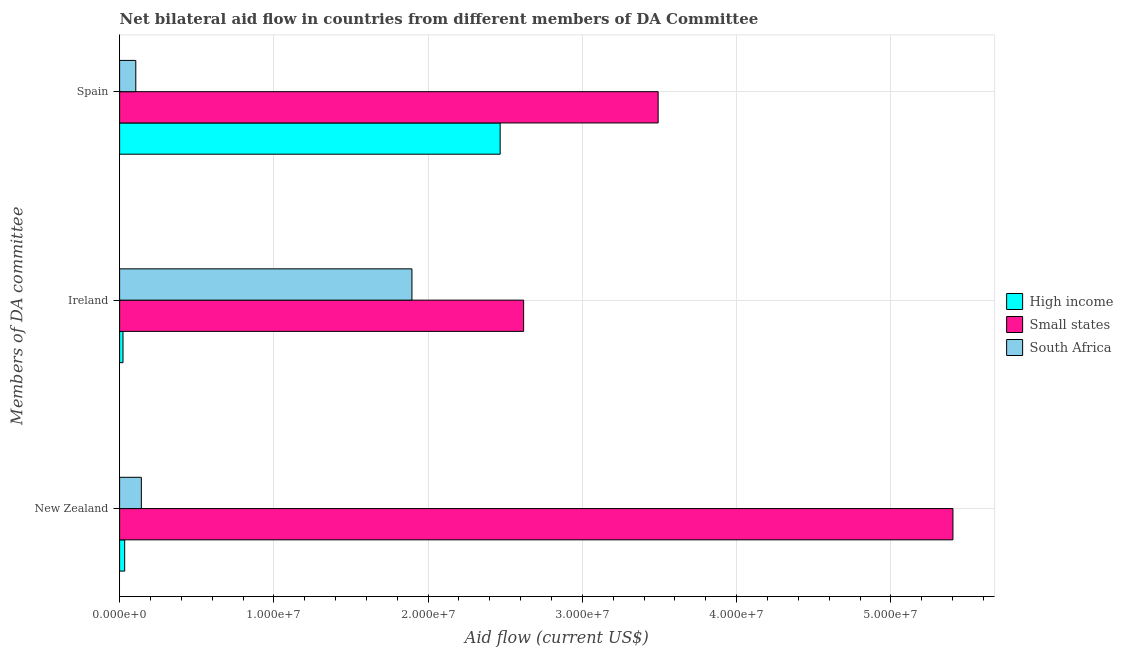How many different coloured bars are there?
Offer a terse response. 3. Are the number of bars on each tick of the Y-axis equal?
Offer a terse response. Yes. How many bars are there on the 3rd tick from the top?
Provide a short and direct response. 3. How many bars are there on the 2nd tick from the bottom?
Provide a short and direct response. 3. What is the label of the 2nd group of bars from the top?
Your answer should be compact. Ireland. What is the amount of aid provided by ireland in Small states?
Your answer should be compact. 2.62e+07. Across all countries, what is the maximum amount of aid provided by new zealand?
Your answer should be compact. 5.40e+07. Across all countries, what is the minimum amount of aid provided by new zealand?
Keep it short and to the point. 3.30e+05. In which country was the amount of aid provided by new zealand maximum?
Give a very brief answer. Small states. In which country was the amount of aid provided by spain minimum?
Provide a short and direct response. South Africa. What is the total amount of aid provided by spain in the graph?
Provide a short and direct response. 6.06e+07. What is the difference between the amount of aid provided by ireland in South Africa and that in High income?
Give a very brief answer. 1.87e+07. What is the difference between the amount of aid provided by spain in Small states and the amount of aid provided by new zealand in High income?
Give a very brief answer. 3.46e+07. What is the average amount of aid provided by spain per country?
Provide a short and direct response. 2.02e+07. What is the difference between the amount of aid provided by spain and amount of aid provided by new zealand in High income?
Offer a terse response. 2.43e+07. What is the ratio of the amount of aid provided by ireland in South Africa to that in High income?
Your answer should be very brief. 86.14. What is the difference between the highest and the second highest amount of aid provided by spain?
Give a very brief answer. 1.02e+07. What is the difference between the highest and the lowest amount of aid provided by new zealand?
Offer a terse response. 5.37e+07. In how many countries, is the amount of aid provided by spain greater than the average amount of aid provided by spain taken over all countries?
Provide a succinct answer. 2. Is the sum of the amount of aid provided by spain in Small states and South Africa greater than the maximum amount of aid provided by ireland across all countries?
Your answer should be compact. Yes. What does the 1st bar from the top in Spain represents?
Offer a very short reply. South Africa. What does the 3rd bar from the bottom in Spain represents?
Keep it short and to the point. South Africa. Is it the case that in every country, the sum of the amount of aid provided by new zealand and amount of aid provided by ireland is greater than the amount of aid provided by spain?
Your response must be concise. No. How many bars are there?
Provide a succinct answer. 9. Are all the bars in the graph horizontal?
Provide a short and direct response. Yes. Does the graph contain any zero values?
Your answer should be very brief. No. How many legend labels are there?
Keep it short and to the point. 3. How are the legend labels stacked?
Your response must be concise. Vertical. What is the title of the graph?
Offer a terse response. Net bilateral aid flow in countries from different members of DA Committee. Does "Cameroon" appear as one of the legend labels in the graph?
Your response must be concise. No. What is the label or title of the Y-axis?
Provide a succinct answer. Members of DA committee. What is the Aid flow (current US$) of Small states in New Zealand?
Your response must be concise. 5.40e+07. What is the Aid flow (current US$) of South Africa in New Zealand?
Provide a succinct answer. 1.41e+06. What is the Aid flow (current US$) of Small states in Ireland?
Ensure brevity in your answer.  2.62e+07. What is the Aid flow (current US$) of South Africa in Ireland?
Your response must be concise. 1.90e+07. What is the Aid flow (current US$) in High income in Spain?
Your answer should be very brief. 2.47e+07. What is the Aid flow (current US$) in Small states in Spain?
Give a very brief answer. 3.49e+07. What is the Aid flow (current US$) in South Africa in Spain?
Your answer should be very brief. 1.05e+06. Across all Members of DA committee, what is the maximum Aid flow (current US$) of High income?
Make the answer very short. 2.47e+07. Across all Members of DA committee, what is the maximum Aid flow (current US$) of Small states?
Your response must be concise. 5.40e+07. Across all Members of DA committee, what is the maximum Aid flow (current US$) in South Africa?
Ensure brevity in your answer.  1.90e+07. Across all Members of DA committee, what is the minimum Aid flow (current US$) in High income?
Provide a succinct answer. 2.20e+05. Across all Members of DA committee, what is the minimum Aid flow (current US$) of Small states?
Offer a terse response. 2.62e+07. Across all Members of DA committee, what is the minimum Aid flow (current US$) of South Africa?
Provide a succinct answer. 1.05e+06. What is the total Aid flow (current US$) of High income in the graph?
Your answer should be compact. 2.52e+07. What is the total Aid flow (current US$) in Small states in the graph?
Ensure brevity in your answer.  1.15e+08. What is the total Aid flow (current US$) of South Africa in the graph?
Give a very brief answer. 2.14e+07. What is the difference between the Aid flow (current US$) of High income in New Zealand and that in Ireland?
Your answer should be compact. 1.10e+05. What is the difference between the Aid flow (current US$) of Small states in New Zealand and that in Ireland?
Make the answer very short. 2.78e+07. What is the difference between the Aid flow (current US$) of South Africa in New Zealand and that in Ireland?
Offer a very short reply. -1.75e+07. What is the difference between the Aid flow (current US$) of High income in New Zealand and that in Spain?
Your answer should be very brief. -2.43e+07. What is the difference between the Aid flow (current US$) in Small states in New Zealand and that in Spain?
Your response must be concise. 1.91e+07. What is the difference between the Aid flow (current US$) of High income in Ireland and that in Spain?
Offer a terse response. -2.44e+07. What is the difference between the Aid flow (current US$) in Small states in Ireland and that in Spain?
Keep it short and to the point. -8.72e+06. What is the difference between the Aid flow (current US$) of South Africa in Ireland and that in Spain?
Your answer should be very brief. 1.79e+07. What is the difference between the Aid flow (current US$) of High income in New Zealand and the Aid flow (current US$) of Small states in Ireland?
Provide a short and direct response. -2.59e+07. What is the difference between the Aid flow (current US$) of High income in New Zealand and the Aid flow (current US$) of South Africa in Ireland?
Your response must be concise. -1.86e+07. What is the difference between the Aid flow (current US$) in Small states in New Zealand and the Aid flow (current US$) in South Africa in Ireland?
Make the answer very short. 3.51e+07. What is the difference between the Aid flow (current US$) in High income in New Zealand and the Aid flow (current US$) in Small states in Spain?
Provide a succinct answer. -3.46e+07. What is the difference between the Aid flow (current US$) of High income in New Zealand and the Aid flow (current US$) of South Africa in Spain?
Provide a short and direct response. -7.20e+05. What is the difference between the Aid flow (current US$) of Small states in New Zealand and the Aid flow (current US$) of South Africa in Spain?
Your answer should be compact. 5.30e+07. What is the difference between the Aid flow (current US$) in High income in Ireland and the Aid flow (current US$) in Small states in Spain?
Your answer should be very brief. -3.47e+07. What is the difference between the Aid flow (current US$) of High income in Ireland and the Aid flow (current US$) of South Africa in Spain?
Give a very brief answer. -8.30e+05. What is the difference between the Aid flow (current US$) in Small states in Ireland and the Aid flow (current US$) in South Africa in Spain?
Give a very brief answer. 2.51e+07. What is the average Aid flow (current US$) in High income per Members of DA committee?
Your answer should be compact. 8.41e+06. What is the average Aid flow (current US$) of Small states per Members of DA committee?
Your answer should be compact. 3.84e+07. What is the average Aid flow (current US$) in South Africa per Members of DA committee?
Ensure brevity in your answer.  7.14e+06. What is the difference between the Aid flow (current US$) in High income and Aid flow (current US$) in Small states in New Zealand?
Offer a very short reply. -5.37e+07. What is the difference between the Aid flow (current US$) in High income and Aid flow (current US$) in South Africa in New Zealand?
Make the answer very short. -1.08e+06. What is the difference between the Aid flow (current US$) in Small states and Aid flow (current US$) in South Africa in New Zealand?
Your response must be concise. 5.26e+07. What is the difference between the Aid flow (current US$) of High income and Aid flow (current US$) of Small states in Ireland?
Make the answer very short. -2.60e+07. What is the difference between the Aid flow (current US$) in High income and Aid flow (current US$) in South Africa in Ireland?
Make the answer very short. -1.87e+07. What is the difference between the Aid flow (current US$) of Small states and Aid flow (current US$) of South Africa in Ireland?
Keep it short and to the point. 7.24e+06. What is the difference between the Aid flow (current US$) of High income and Aid flow (current US$) of Small states in Spain?
Offer a very short reply. -1.02e+07. What is the difference between the Aid flow (current US$) in High income and Aid flow (current US$) in South Africa in Spain?
Make the answer very short. 2.36e+07. What is the difference between the Aid flow (current US$) of Small states and Aid flow (current US$) of South Africa in Spain?
Offer a very short reply. 3.39e+07. What is the ratio of the Aid flow (current US$) of Small states in New Zealand to that in Ireland?
Offer a very short reply. 2.06. What is the ratio of the Aid flow (current US$) of South Africa in New Zealand to that in Ireland?
Offer a very short reply. 0.07. What is the ratio of the Aid flow (current US$) of High income in New Zealand to that in Spain?
Provide a succinct answer. 0.01. What is the ratio of the Aid flow (current US$) in Small states in New Zealand to that in Spain?
Ensure brevity in your answer.  1.55. What is the ratio of the Aid flow (current US$) in South Africa in New Zealand to that in Spain?
Give a very brief answer. 1.34. What is the ratio of the Aid flow (current US$) in High income in Ireland to that in Spain?
Your response must be concise. 0.01. What is the ratio of the Aid flow (current US$) of Small states in Ireland to that in Spain?
Ensure brevity in your answer.  0.75. What is the ratio of the Aid flow (current US$) of South Africa in Ireland to that in Spain?
Make the answer very short. 18.05. What is the difference between the highest and the second highest Aid flow (current US$) of High income?
Provide a short and direct response. 2.43e+07. What is the difference between the highest and the second highest Aid flow (current US$) in Small states?
Your answer should be compact. 1.91e+07. What is the difference between the highest and the second highest Aid flow (current US$) in South Africa?
Offer a very short reply. 1.75e+07. What is the difference between the highest and the lowest Aid flow (current US$) of High income?
Give a very brief answer. 2.44e+07. What is the difference between the highest and the lowest Aid flow (current US$) of Small states?
Offer a terse response. 2.78e+07. What is the difference between the highest and the lowest Aid flow (current US$) in South Africa?
Make the answer very short. 1.79e+07. 